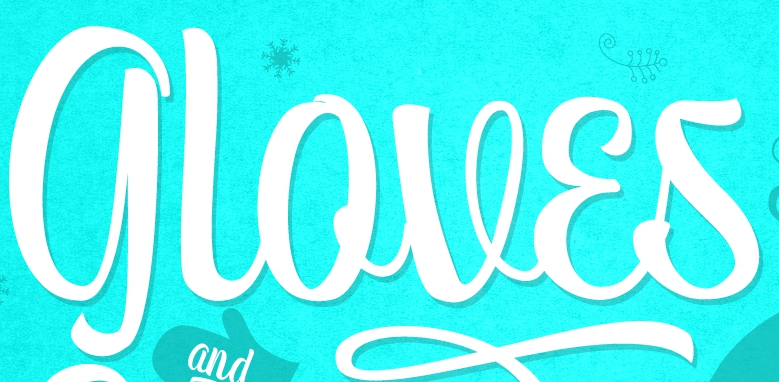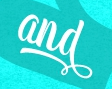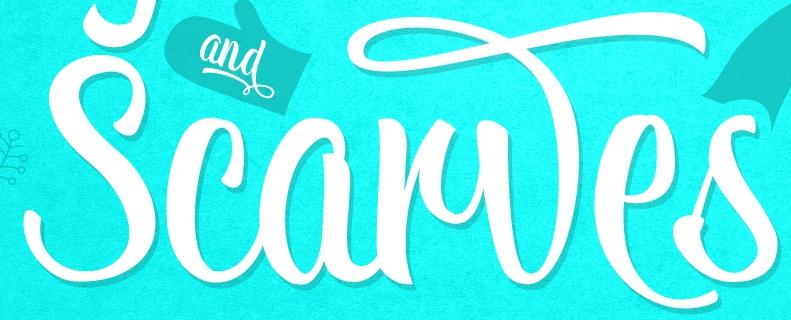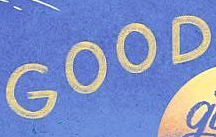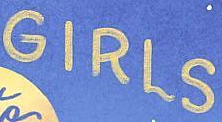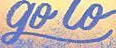What text is displayed in these images sequentially, separated by a semicolon? gloves; and; Scarwes; GOOD; GIRLS; go 